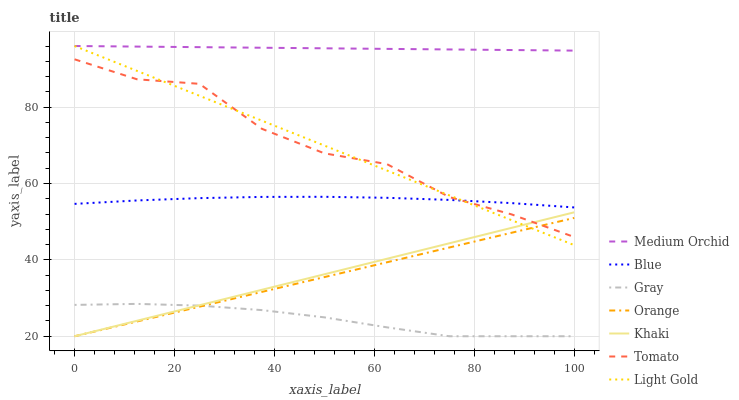Does Gray have the minimum area under the curve?
Answer yes or no. Yes. Does Medium Orchid have the maximum area under the curve?
Answer yes or no. Yes. Does Khaki have the minimum area under the curve?
Answer yes or no. No. Does Khaki have the maximum area under the curve?
Answer yes or no. No. Is Medium Orchid the smoothest?
Answer yes or no. Yes. Is Tomato the roughest?
Answer yes or no. Yes. Is Gray the smoothest?
Answer yes or no. No. Is Gray the roughest?
Answer yes or no. No. Does Gray have the lowest value?
Answer yes or no. Yes. Does Medium Orchid have the lowest value?
Answer yes or no. No. Does Light Gold have the highest value?
Answer yes or no. Yes. Does Khaki have the highest value?
Answer yes or no. No. Is Khaki less than Medium Orchid?
Answer yes or no. Yes. Is Medium Orchid greater than Gray?
Answer yes or no. Yes. Does Khaki intersect Tomato?
Answer yes or no. Yes. Is Khaki less than Tomato?
Answer yes or no. No. Is Khaki greater than Tomato?
Answer yes or no. No. Does Khaki intersect Medium Orchid?
Answer yes or no. No. 